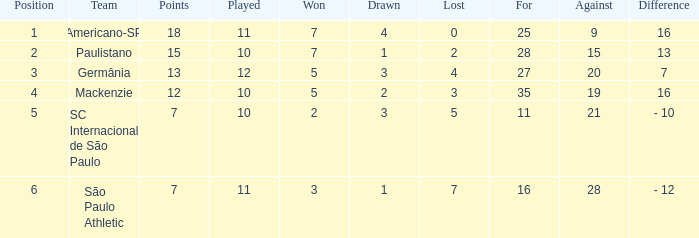Determine the largest number when there is a 7-unit difference between two numbers. 27.0. 